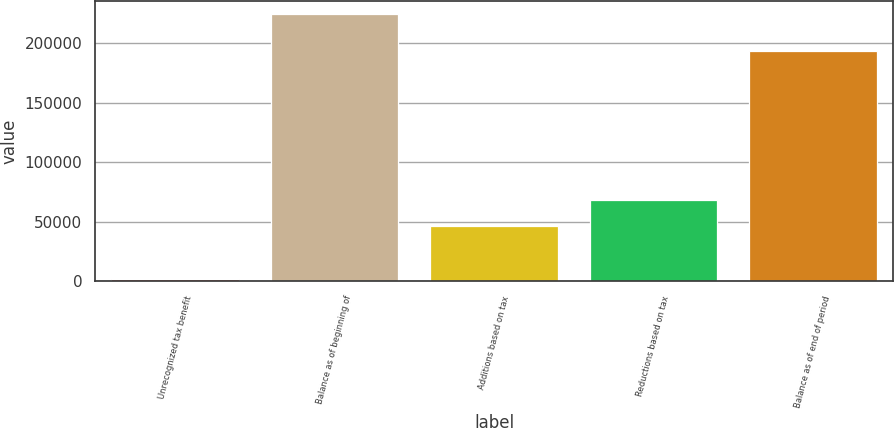<chart> <loc_0><loc_0><loc_500><loc_500><bar_chart><fcel>Unrecognized tax benefit<fcel>Balance as of beginning of<fcel>Additions based on tax<fcel>Reductions based on tax<fcel>Balance as of end of period<nl><fcel>2010<fcel>224029<fcel>46413.8<fcel>68615.7<fcel>193320<nl></chart> 